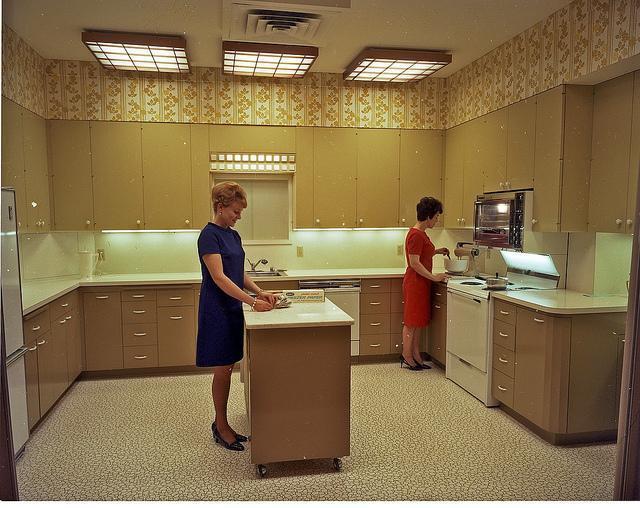How many women are in this picture?
Give a very brief answer. 2. How many people are visible?
Give a very brief answer. 2. How many cups of sugar in the recipe?
Give a very brief answer. 0. 